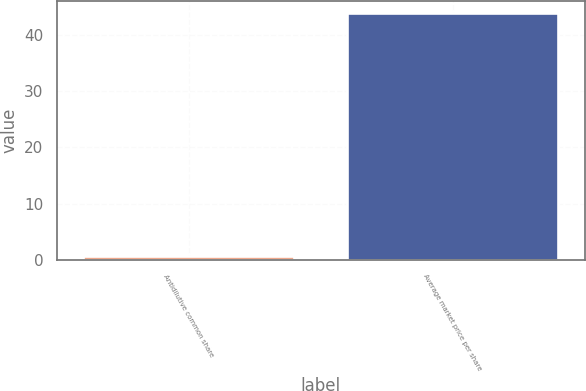<chart> <loc_0><loc_0><loc_500><loc_500><bar_chart><fcel>Antidilutive common share<fcel>Average market price per share<nl><fcel>0.7<fcel>43.8<nl></chart> 